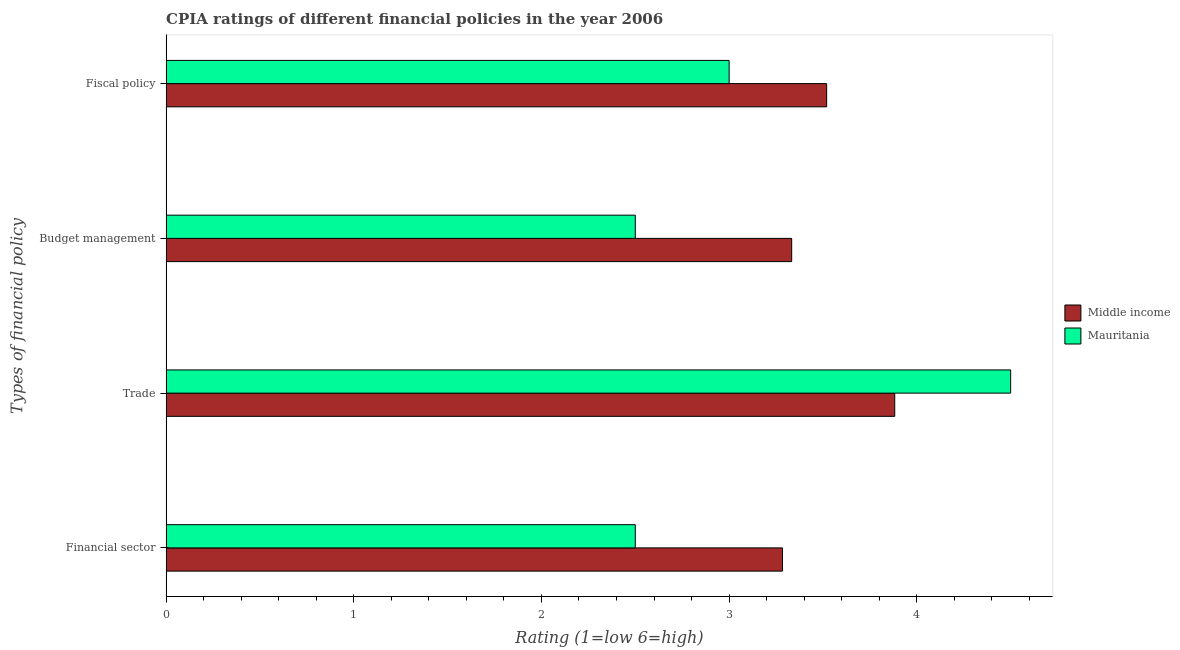How many different coloured bars are there?
Your answer should be very brief. 2. Are the number of bars per tick equal to the number of legend labels?
Offer a terse response. Yes. How many bars are there on the 1st tick from the bottom?
Make the answer very short. 2. What is the label of the 3rd group of bars from the top?
Make the answer very short. Trade. Across all countries, what is the maximum cpia rating of financial sector?
Keep it short and to the point. 3.28. In which country was the cpia rating of fiscal policy minimum?
Your answer should be very brief. Mauritania. What is the total cpia rating of trade in the graph?
Your response must be concise. 8.38. What is the difference between the cpia rating of fiscal policy in Mauritania and that in Middle income?
Keep it short and to the point. -0.52. What is the difference between the cpia rating of financial sector in Mauritania and the cpia rating of budget management in Middle income?
Your answer should be compact. -0.83. What is the average cpia rating of budget management per country?
Your answer should be compact. 2.92. What is the difference between the cpia rating of fiscal policy and cpia rating of financial sector in Middle income?
Make the answer very short. 0.24. In how many countries, is the cpia rating of fiscal policy greater than 3.8 ?
Your answer should be compact. 0. What is the ratio of the cpia rating of financial sector in Middle income to that in Mauritania?
Offer a very short reply. 1.31. Is the difference between the cpia rating of trade in Mauritania and Middle income greater than the difference between the cpia rating of budget management in Mauritania and Middle income?
Make the answer very short. Yes. What is the difference between the highest and the second highest cpia rating of fiscal policy?
Provide a short and direct response. 0.52. What is the difference between the highest and the lowest cpia rating of trade?
Offer a terse response. 0.62. In how many countries, is the cpia rating of trade greater than the average cpia rating of trade taken over all countries?
Make the answer very short. 1. Is the sum of the cpia rating of fiscal policy in Mauritania and Middle income greater than the maximum cpia rating of budget management across all countries?
Keep it short and to the point. Yes. What does the 2nd bar from the top in Fiscal policy represents?
Keep it short and to the point. Middle income. What does the 2nd bar from the bottom in Budget management represents?
Give a very brief answer. Mauritania. Are all the bars in the graph horizontal?
Offer a very short reply. Yes. Are the values on the major ticks of X-axis written in scientific E-notation?
Keep it short and to the point. No. Does the graph contain any zero values?
Provide a succinct answer. No. Where does the legend appear in the graph?
Provide a short and direct response. Center right. What is the title of the graph?
Keep it short and to the point. CPIA ratings of different financial policies in the year 2006. Does "Japan" appear as one of the legend labels in the graph?
Your answer should be compact. No. What is the label or title of the Y-axis?
Your answer should be compact. Types of financial policy. What is the Rating (1=low 6=high) of Middle income in Financial sector?
Your answer should be very brief. 3.28. What is the Rating (1=low 6=high) of Middle income in Trade?
Your response must be concise. 3.88. What is the Rating (1=low 6=high) in Mauritania in Trade?
Provide a short and direct response. 4.5. What is the Rating (1=low 6=high) in Middle income in Budget management?
Ensure brevity in your answer.  3.33. What is the Rating (1=low 6=high) in Middle income in Fiscal policy?
Provide a succinct answer. 3.52. What is the Rating (1=low 6=high) in Mauritania in Fiscal policy?
Provide a succinct answer. 3. Across all Types of financial policy, what is the maximum Rating (1=low 6=high) of Middle income?
Ensure brevity in your answer.  3.88. Across all Types of financial policy, what is the minimum Rating (1=low 6=high) in Middle income?
Keep it short and to the point. 3.28. Across all Types of financial policy, what is the minimum Rating (1=low 6=high) of Mauritania?
Your response must be concise. 2.5. What is the total Rating (1=low 6=high) in Middle income in the graph?
Offer a very short reply. 14.02. What is the total Rating (1=low 6=high) of Mauritania in the graph?
Offer a terse response. 12.5. What is the difference between the Rating (1=low 6=high) of Middle income in Financial sector and that in Trade?
Offer a terse response. -0.6. What is the difference between the Rating (1=low 6=high) in Middle income in Financial sector and that in Budget management?
Give a very brief answer. -0.05. What is the difference between the Rating (1=low 6=high) in Middle income in Financial sector and that in Fiscal policy?
Provide a succinct answer. -0.24. What is the difference between the Rating (1=low 6=high) of Middle income in Trade and that in Budget management?
Offer a very short reply. 0.55. What is the difference between the Rating (1=low 6=high) of Middle income in Trade and that in Fiscal policy?
Provide a short and direct response. 0.36. What is the difference between the Rating (1=low 6=high) of Middle income in Budget management and that in Fiscal policy?
Offer a very short reply. -0.19. What is the difference between the Rating (1=low 6=high) in Mauritania in Budget management and that in Fiscal policy?
Your answer should be compact. -0.5. What is the difference between the Rating (1=low 6=high) of Middle income in Financial sector and the Rating (1=low 6=high) of Mauritania in Trade?
Your answer should be compact. -1.22. What is the difference between the Rating (1=low 6=high) in Middle income in Financial sector and the Rating (1=low 6=high) in Mauritania in Budget management?
Provide a short and direct response. 0.78. What is the difference between the Rating (1=low 6=high) of Middle income in Financial sector and the Rating (1=low 6=high) of Mauritania in Fiscal policy?
Your answer should be very brief. 0.28. What is the difference between the Rating (1=low 6=high) in Middle income in Trade and the Rating (1=low 6=high) in Mauritania in Budget management?
Your answer should be compact. 1.38. What is the difference between the Rating (1=low 6=high) of Middle income in Trade and the Rating (1=low 6=high) of Mauritania in Fiscal policy?
Provide a succinct answer. 0.88. What is the average Rating (1=low 6=high) of Middle income per Types of financial policy?
Provide a succinct answer. 3.5. What is the average Rating (1=low 6=high) of Mauritania per Types of financial policy?
Provide a succinct answer. 3.12. What is the difference between the Rating (1=low 6=high) of Middle income and Rating (1=low 6=high) of Mauritania in Financial sector?
Offer a very short reply. 0.78. What is the difference between the Rating (1=low 6=high) in Middle income and Rating (1=low 6=high) in Mauritania in Trade?
Your answer should be compact. -0.62. What is the difference between the Rating (1=low 6=high) in Middle income and Rating (1=low 6=high) in Mauritania in Fiscal policy?
Provide a succinct answer. 0.52. What is the ratio of the Rating (1=low 6=high) in Middle income in Financial sector to that in Trade?
Keep it short and to the point. 0.85. What is the ratio of the Rating (1=low 6=high) of Mauritania in Financial sector to that in Trade?
Your answer should be very brief. 0.56. What is the ratio of the Rating (1=low 6=high) in Middle income in Financial sector to that in Fiscal policy?
Provide a succinct answer. 0.93. What is the ratio of the Rating (1=low 6=high) in Mauritania in Financial sector to that in Fiscal policy?
Your response must be concise. 0.83. What is the ratio of the Rating (1=low 6=high) of Middle income in Trade to that in Budget management?
Your response must be concise. 1.16. What is the ratio of the Rating (1=low 6=high) of Mauritania in Trade to that in Budget management?
Keep it short and to the point. 1.8. What is the ratio of the Rating (1=low 6=high) of Middle income in Trade to that in Fiscal policy?
Provide a short and direct response. 1.1. What is the ratio of the Rating (1=low 6=high) of Mauritania in Trade to that in Fiscal policy?
Your answer should be very brief. 1.5. What is the ratio of the Rating (1=low 6=high) in Middle income in Budget management to that in Fiscal policy?
Make the answer very short. 0.95. What is the ratio of the Rating (1=low 6=high) of Mauritania in Budget management to that in Fiscal policy?
Offer a terse response. 0.83. What is the difference between the highest and the second highest Rating (1=low 6=high) of Middle income?
Keep it short and to the point. 0.36. What is the difference between the highest and the second highest Rating (1=low 6=high) of Mauritania?
Offer a terse response. 1.5. What is the difference between the highest and the lowest Rating (1=low 6=high) of Middle income?
Make the answer very short. 0.6. What is the difference between the highest and the lowest Rating (1=low 6=high) in Mauritania?
Give a very brief answer. 2. 